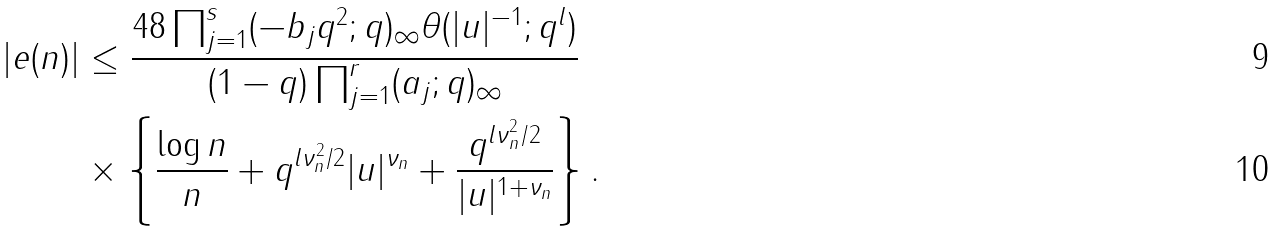Convert formula to latex. <formula><loc_0><loc_0><loc_500><loc_500>| e ( n ) | & \leq \frac { 4 8 \prod _ { j = 1 } ^ { s } ( - b _ { j } q ^ { 2 } ; q ) _ { \infty } \theta ( | u | ^ { - 1 } ; q ^ { l } ) } { ( 1 - q ) \prod _ { j = 1 } ^ { r } ( a _ { j } ; q ) _ { \infty } } \\ & \times \left \{ \frac { \log n } { n } + q ^ { l \nu _ { n } ^ { 2 } / 2 } | u | ^ { \nu _ { n } } + \frac { q ^ { { l \nu } _ { n } ^ { 2 } / 2 } } { | u | ^ { 1 + \nu _ { n } } } \right \} .</formula> 